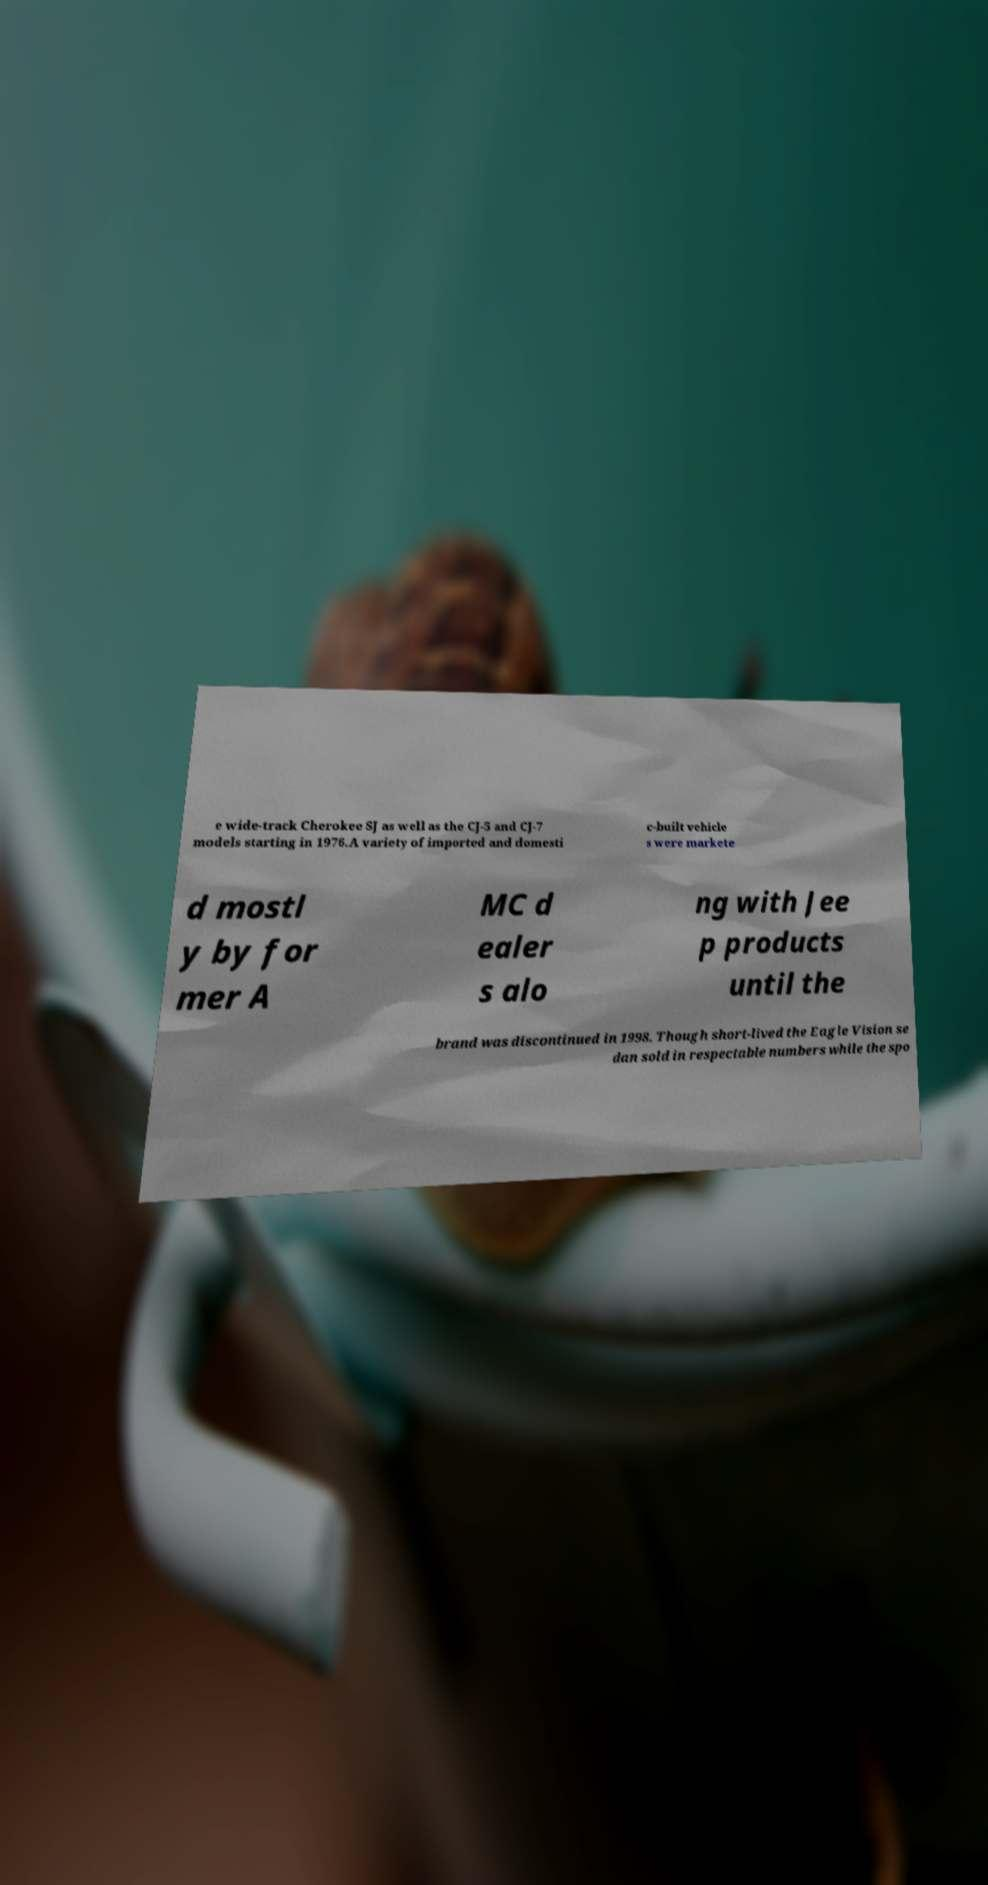I need the written content from this picture converted into text. Can you do that? e wide-track Cherokee SJ as well as the CJ-5 and CJ-7 models starting in 1976.A variety of imported and domesti c-built vehicle s were markete d mostl y by for mer A MC d ealer s alo ng with Jee p products until the brand was discontinued in 1998. Though short-lived the Eagle Vision se dan sold in respectable numbers while the spo 